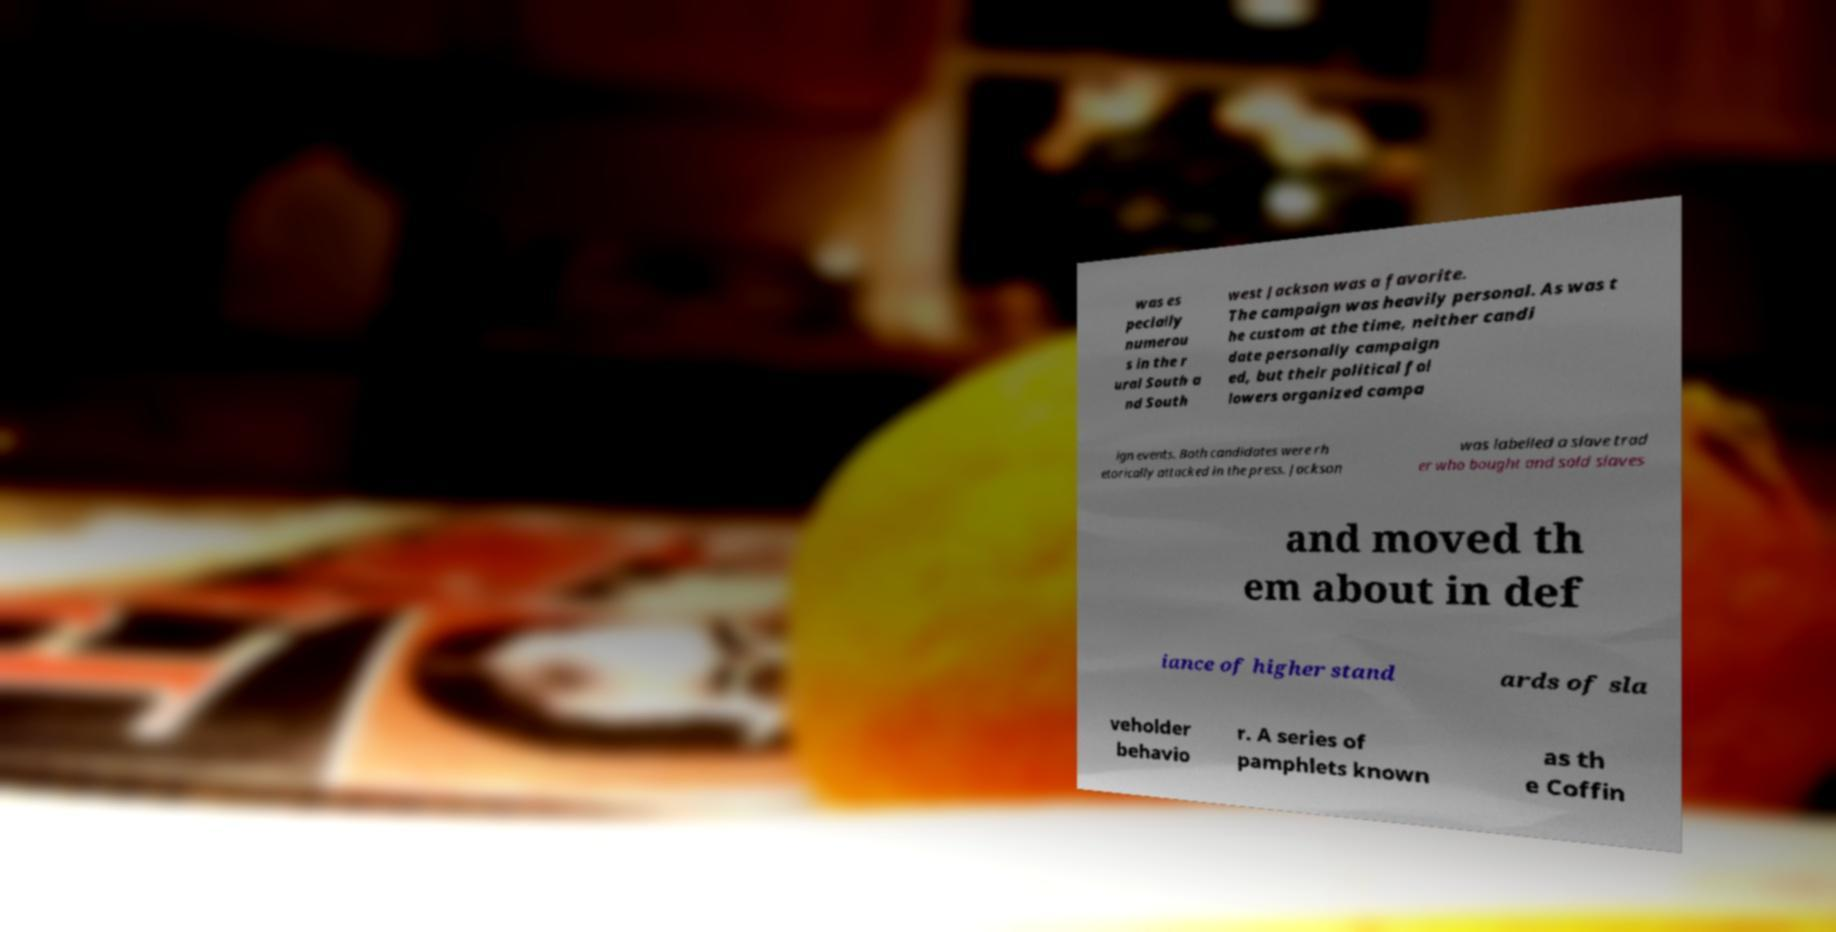Could you assist in decoding the text presented in this image and type it out clearly? was es pecially numerou s in the r ural South a nd South west Jackson was a favorite. The campaign was heavily personal. As was t he custom at the time, neither candi date personally campaign ed, but their political fol lowers organized campa ign events. Both candidates were rh etorically attacked in the press. Jackson was labelled a slave trad er who bought and sold slaves and moved th em about in def iance of higher stand ards of sla veholder behavio r. A series of pamphlets known as th e Coffin 